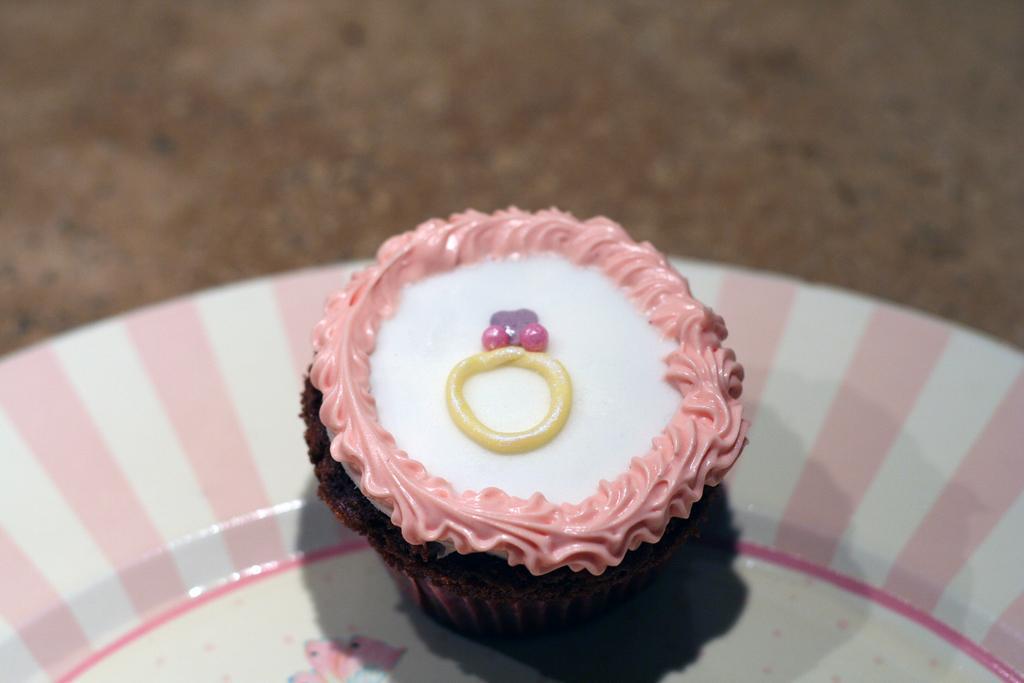Describe this image in one or two sentences. In this image I can see a plate which is white and pink in color is on the brown in color surface. On the plate I can see a cupcake which is brown, white, pink and yellow in color. 